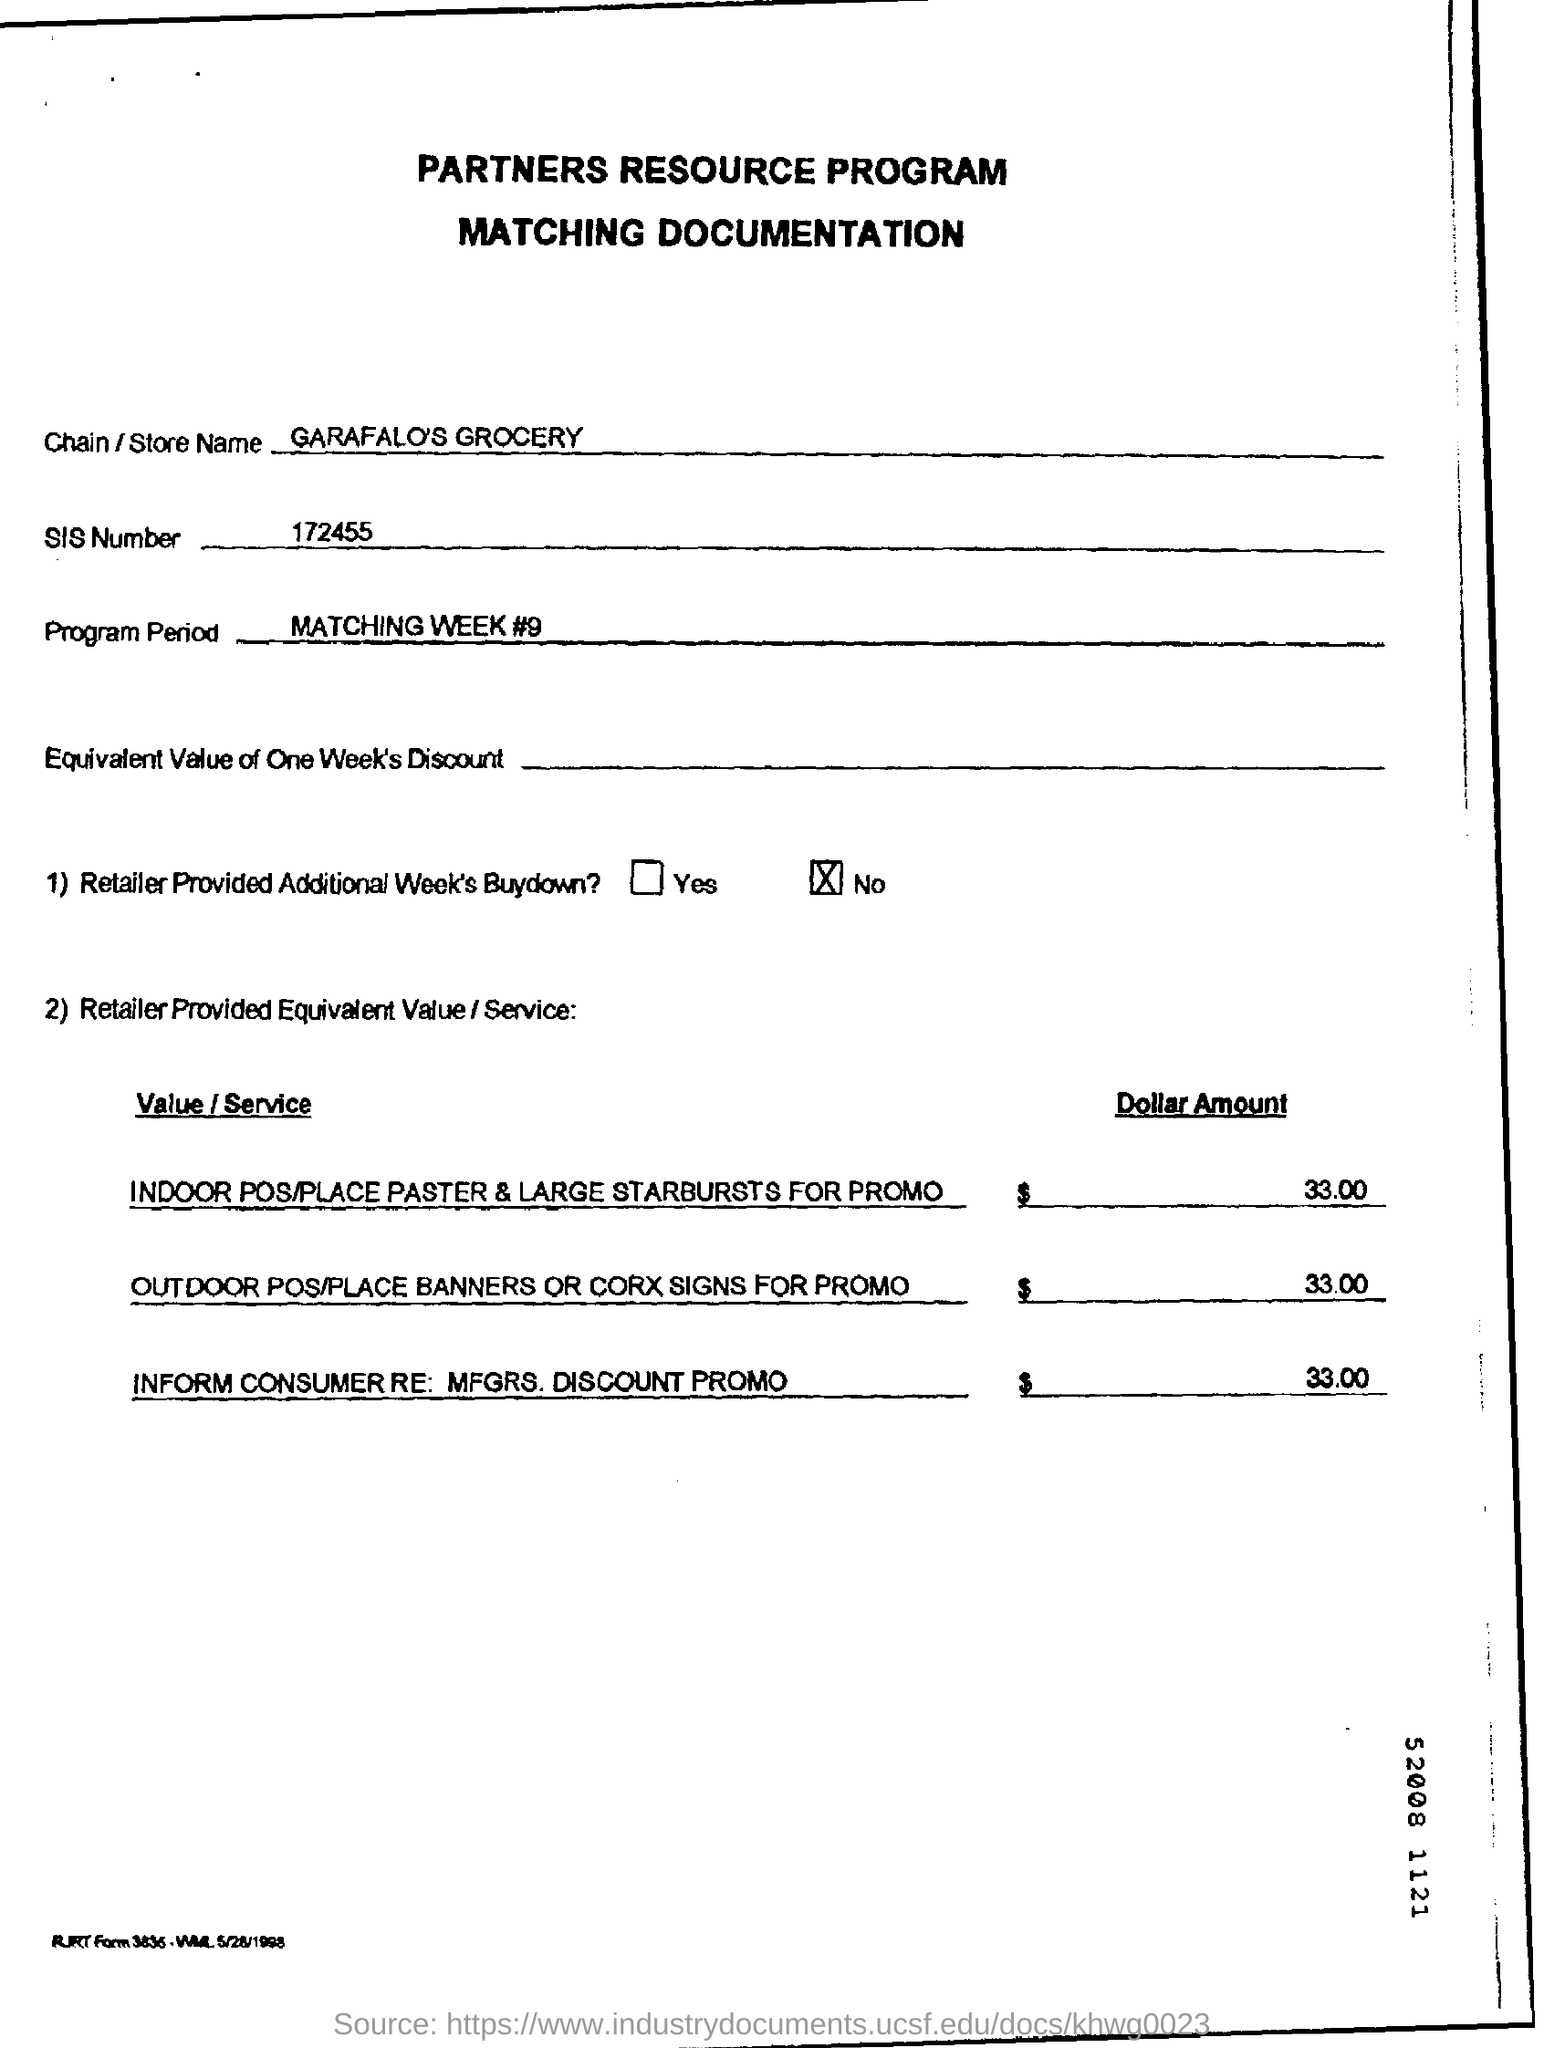What is the sis number?
Your response must be concise. 172455. What is the store name mentioned in the documentation?
Give a very brief answer. Garafalo's grocery. What is the program period mentioned?
Offer a very short reply. Matching Week #9. What is the dollar amount mentioned in the document?
Provide a short and direct response. 33.00. 